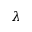Convert formula to latex. <formula><loc_0><loc_0><loc_500><loc_500>\lambda</formula> 